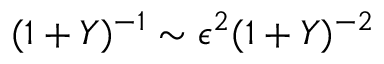Convert formula to latex. <formula><loc_0><loc_0><loc_500><loc_500>( 1 + Y ) ^ { - 1 } \sim \epsilon ^ { 2 } ( 1 + Y ) ^ { - 2 }</formula> 